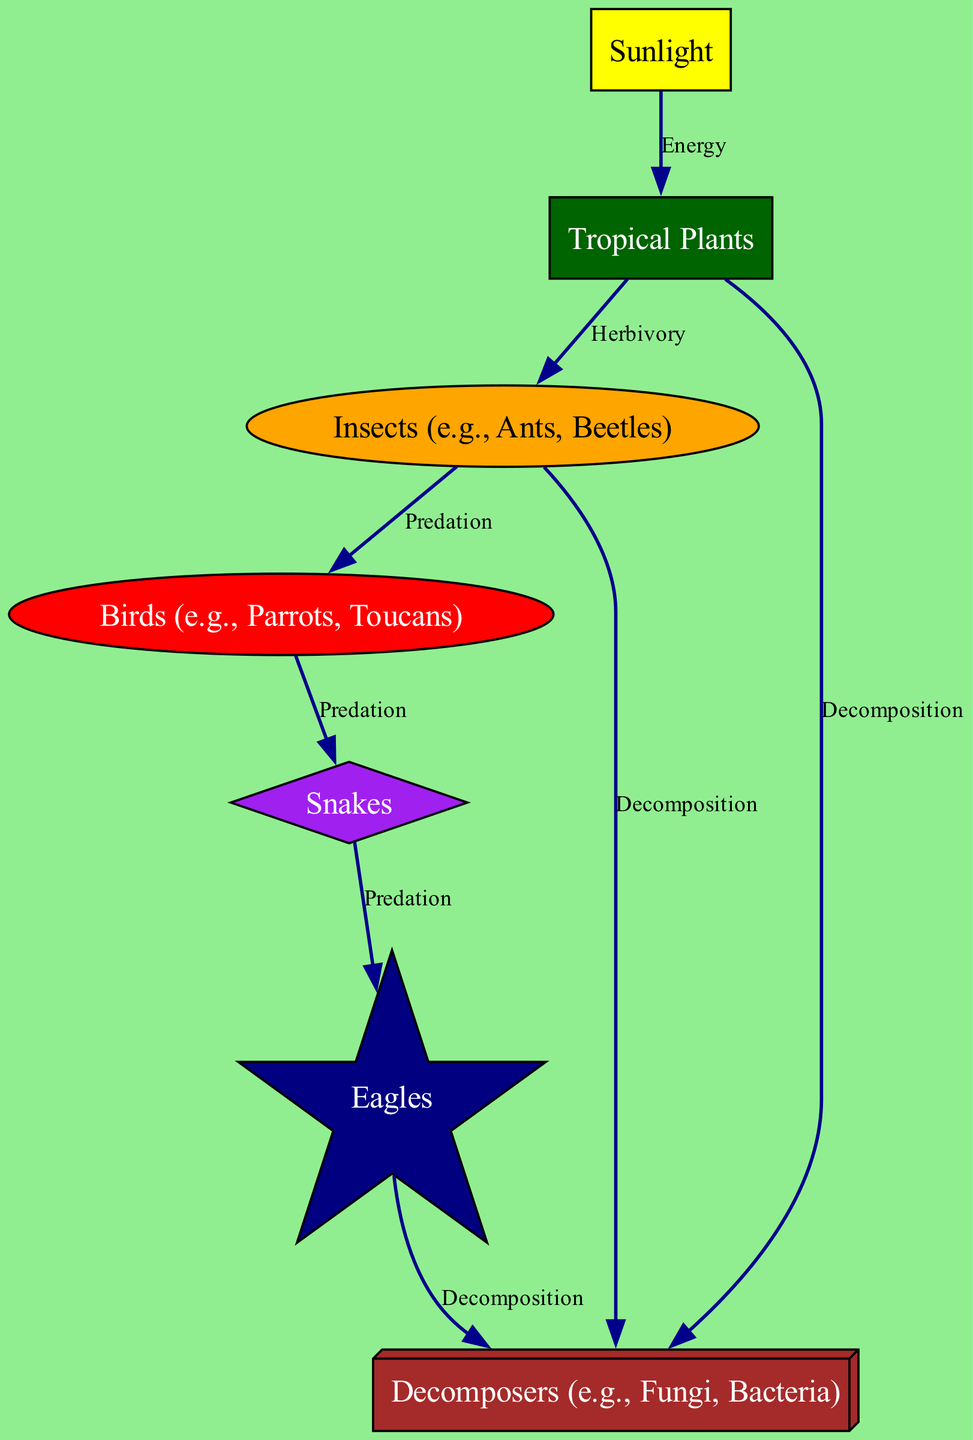What is the apex predator in this food chain? The apex predator is the top of the food chain and is identified in the diagram as "Eagles."
Answer: Eagles How many primary consumers are present in the food chain? The primary consumers in the diagram are "Insects." There is only one category listed as primary consumers. Therefore, the total number is one.
Answer: One Which node represents the source of energy for the food chain? The source of energy is indicated by “Sunlight,” which feeds into the producers.
Answer: Sunlight What type of consumer are birds classified as? Birds are shown as secondary consumers in the diagram. This classification is indicated in the node label.
Answer: Secondary consumer What is the relationship between insects and birds? The relationship between insects and birds is defined as "Predation," indicating that birds prey on insects for food.
Answer: Predation What connects eagles to decomposers? The connection between eagles and decomposers is labeled as "Decomposition," meaning that the remains of eagles contribute to decomposition processes in the ecosystem.
Answer: Decomposition How many decomposer nodes are present in the food chain? The diagram lists three separate categories labeled as decomposers: "Decomposers (e.g., Fungi, Bacteria)" that receive inputs from multiple sources. Thus, there is one node type, but it interacts with three other food sources.
Answer: One Which organism type feeds on snakes? Snakes are consumed by "Eagles," depicted in the diagram as the apex predator, highlighting the predator-prey relationship.
Answer: Eagles What is the first step in the food chain? The first step depicted in the diagram starts with "Sunlight," which is the initial energy source for the entire food chain.
Answer: Sunlight 